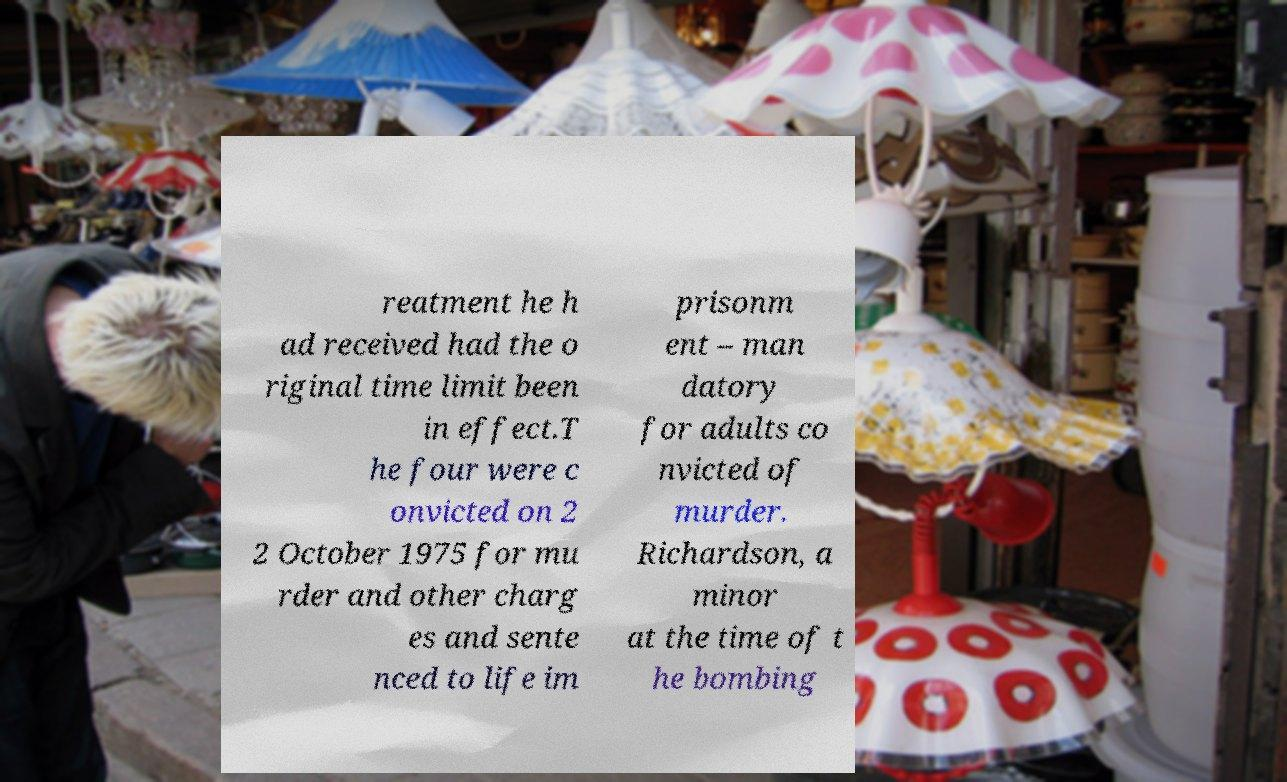I need the written content from this picture converted into text. Can you do that? reatment he h ad received had the o riginal time limit been in effect.T he four were c onvicted on 2 2 October 1975 for mu rder and other charg es and sente nced to life im prisonm ent – man datory for adults co nvicted of murder. Richardson, a minor at the time of t he bombing 